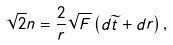Convert formula to latex. <formula><loc_0><loc_0><loc_500><loc_500>\sqrt { 2 } n = \frac { 2 } { r } \sqrt { F } \left ( d \widetilde { t } + d r \right ) ,</formula> 